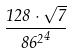<formula> <loc_0><loc_0><loc_500><loc_500>\frac { 1 2 8 \cdot \sqrt { 7 } } { { 8 6 ^ { 2 } } ^ { 4 } }</formula> 